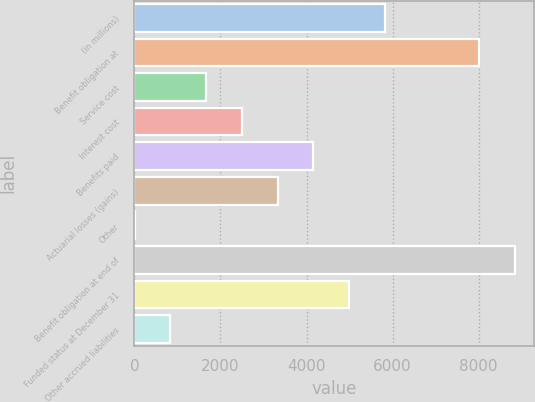<chart> <loc_0><loc_0><loc_500><loc_500><bar_chart><fcel>(in millions)<fcel>Benefit obligation at<fcel>Service cost<fcel>Interest cost<fcel>Benefits paid<fcel>Actuarial losses (gains)<fcel>Other<fcel>Benefit obligation at end of<fcel>Funded status at December 31<fcel>Other accrued liabilities<nl><fcel>5819.6<fcel>8011<fcel>1665.6<fcel>2496.4<fcel>4158<fcel>3327.2<fcel>4<fcel>8841.8<fcel>4988.8<fcel>834.8<nl></chart> 